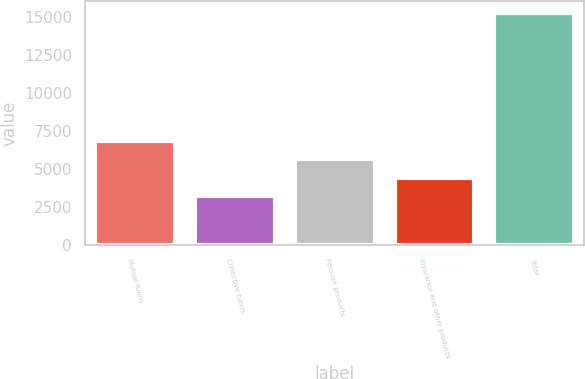Convert chart. <chart><loc_0><loc_0><loc_500><loc_500><bar_chart><fcel>Mutual funds<fcel>Collective funds<fcel>Pension products<fcel>Insurance and other products<fcel>Total<nl><fcel>6829<fcel>3199<fcel>5619<fcel>4409<fcel>15299<nl></chart> 